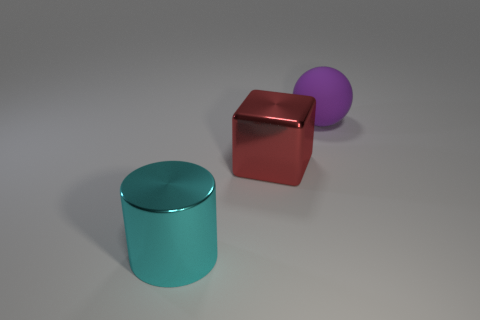Add 2 big spheres. How many objects exist? 5 Subtract all cubes. How many objects are left? 2 Add 1 red metallic objects. How many red metallic objects exist? 2 Subtract 1 cyan cylinders. How many objects are left? 2 Subtract all small brown matte things. Subtract all big matte things. How many objects are left? 2 Add 1 cylinders. How many cylinders are left? 2 